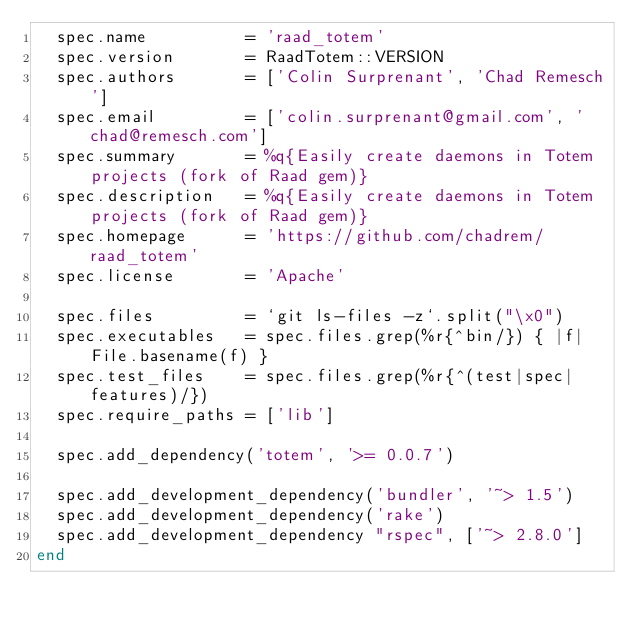<code> <loc_0><loc_0><loc_500><loc_500><_Ruby_>  spec.name          = 'raad_totem'
  spec.version       = RaadTotem::VERSION
  spec.authors       = ['Colin Surprenant', 'Chad Remesch']
  spec.email         = ['colin.surprenant@gmail.com', 'chad@remesch.com']
  spec.summary       = %q{Easily create daemons in Totem projects (fork of Raad gem)}
  spec.description   = %q{Easily create daemons in Totem projects (fork of Raad gem)}
  spec.homepage      = 'https://github.com/chadrem/raad_totem'
  spec.license       = 'Apache'

  spec.files         = `git ls-files -z`.split("\x0")
  spec.executables   = spec.files.grep(%r{^bin/}) { |f| File.basename(f) }
  spec.test_files    = spec.files.grep(%r{^(test|spec|features)/})
  spec.require_paths = ['lib']

  spec.add_dependency('totem', '>= 0.0.7')

  spec.add_development_dependency('bundler', '~> 1.5')
  spec.add_development_dependency('rake')
  spec.add_development_dependency "rspec", ['~> 2.8.0']
end
</code> 